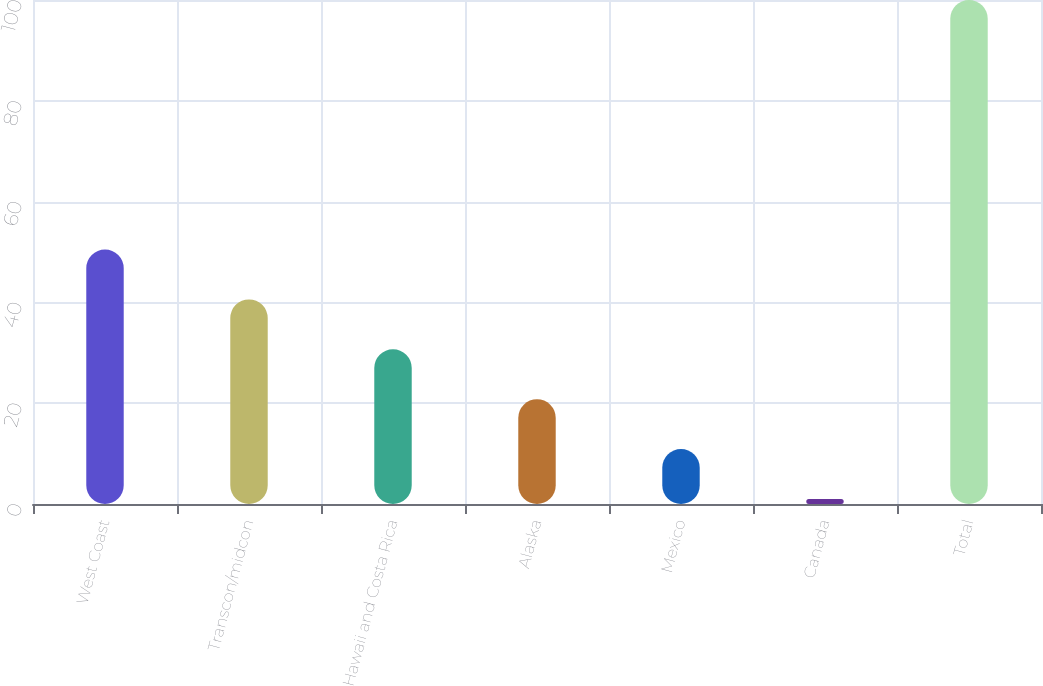Convert chart. <chart><loc_0><loc_0><loc_500><loc_500><bar_chart><fcel>West Coast<fcel>Transcon/midcon<fcel>Hawaii and Costa Rica<fcel>Alaska<fcel>Mexico<fcel>Canada<fcel>Total<nl><fcel>50.5<fcel>40.6<fcel>30.7<fcel>20.8<fcel>10.9<fcel>1<fcel>100<nl></chart> 